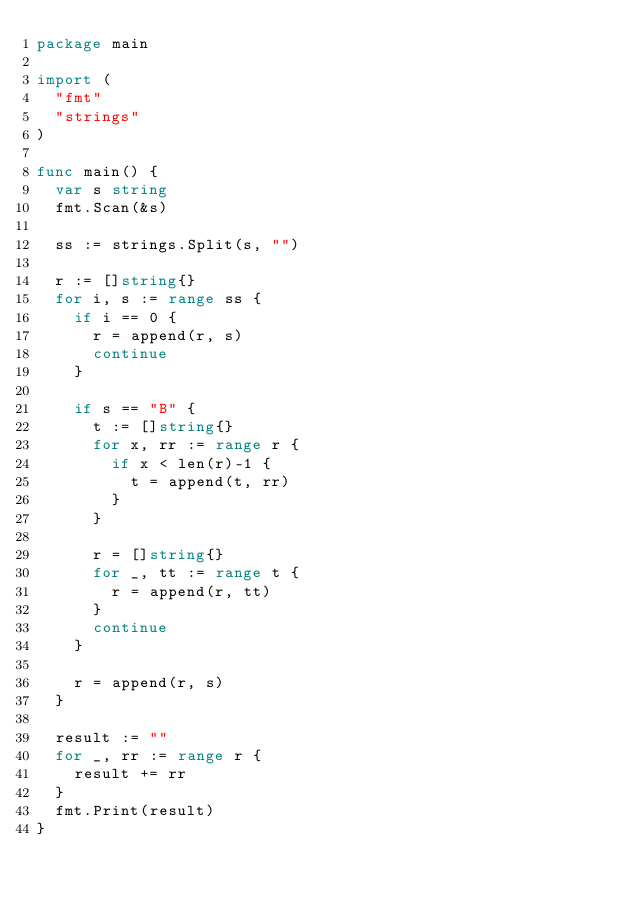<code> <loc_0><loc_0><loc_500><loc_500><_Go_>package main

import (
	"fmt"
	"strings"
)

func main() {
	var s string
	fmt.Scan(&s)

	ss := strings.Split(s, "")

	r := []string{}
	for i, s := range ss {
		if i == 0 {
			r = append(r, s)
			continue
		}

		if s == "B" {
			t := []string{}
			for x, rr := range r {
				if x < len(r)-1 {
					t = append(t, rr)
				}
			}

			r = []string{}
			for _, tt := range t {
				r = append(r, tt)
			}
			continue
		}

		r = append(r, s)
	}

	result := ""
	for _, rr := range r {
		result += rr
	}
	fmt.Print(result)
}
</code> 